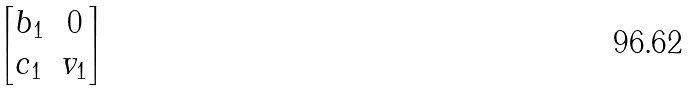<formula> <loc_0><loc_0><loc_500><loc_500>\begin{bmatrix} b _ { 1 } & 0 \\ c _ { 1 } & v _ { 1 } \end{bmatrix}</formula> 